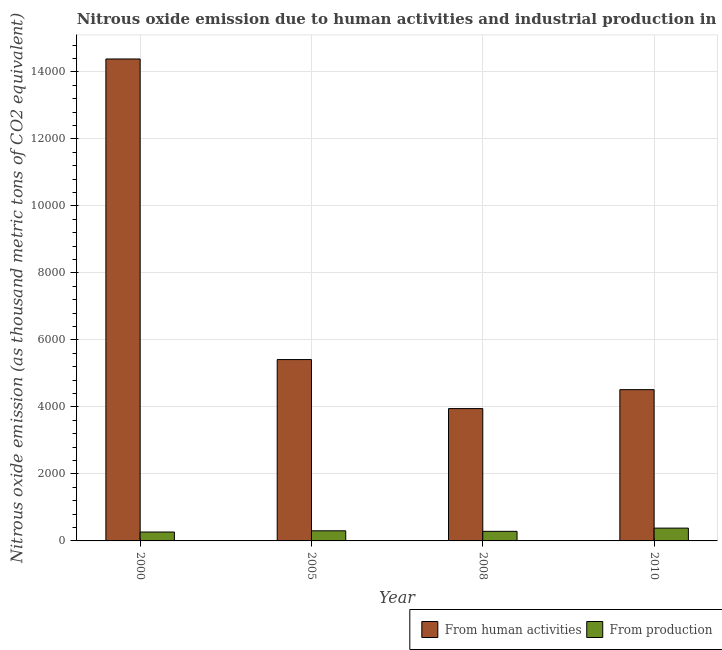How many different coloured bars are there?
Your answer should be very brief. 2. Are the number of bars per tick equal to the number of legend labels?
Provide a succinct answer. Yes. How many bars are there on the 1st tick from the left?
Provide a short and direct response. 2. What is the label of the 2nd group of bars from the left?
Give a very brief answer. 2005. What is the amount of emissions generated from industries in 2010?
Your answer should be compact. 382.1. Across all years, what is the maximum amount of emissions generated from industries?
Give a very brief answer. 382.1. Across all years, what is the minimum amount of emissions from human activities?
Keep it short and to the point. 3950.2. What is the total amount of emissions generated from industries in the graph?
Your answer should be very brief. 1236.1. What is the difference between the amount of emissions generated from industries in 2000 and that in 2010?
Give a very brief answer. -116.5. What is the difference between the amount of emissions generated from industries in 2000 and the amount of emissions from human activities in 2008?
Your answer should be compact. -20.7. What is the average amount of emissions generated from industries per year?
Your answer should be compact. 309.02. In how many years, is the amount of emissions from human activities greater than 12800 thousand metric tons?
Provide a short and direct response. 1. What is the ratio of the amount of emissions generated from industries in 2000 to that in 2008?
Make the answer very short. 0.93. Is the amount of emissions generated from industries in 2005 less than that in 2008?
Keep it short and to the point. No. Is the difference between the amount of emissions generated from industries in 2005 and 2010 greater than the difference between the amount of emissions from human activities in 2005 and 2010?
Your response must be concise. No. What is the difference between the highest and the lowest amount of emissions generated from industries?
Give a very brief answer. 116.5. In how many years, is the amount of emissions from human activities greater than the average amount of emissions from human activities taken over all years?
Provide a succinct answer. 1. Is the sum of the amount of emissions generated from industries in 2005 and 2008 greater than the maximum amount of emissions from human activities across all years?
Make the answer very short. Yes. What does the 1st bar from the left in 2008 represents?
Your answer should be compact. From human activities. What does the 1st bar from the right in 2000 represents?
Offer a very short reply. From production. How many bars are there?
Your answer should be compact. 8. Does the graph contain any zero values?
Your answer should be compact. No. Does the graph contain grids?
Ensure brevity in your answer.  Yes. How many legend labels are there?
Give a very brief answer. 2. How are the legend labels stacked?
Your answer should be very brief. Horizontal. What is the title of the graph?
Provide a succinct answer. Nitrous oxide emission due to human activities and industrial production in Guatemala. What is the label or title of the X-axis?
Your answer should be compact. Year. What is the label or title of the Y-axis?
Provide a short and direct response. Nitrous oxide emission (as thousand metric tons of CO2 equivalent). What is the Nitrous oxide emission (as thousand metric tons of CO2 equivalent) of From human activities in 2000?
Offer a very short reply. 1.44e+04. What is the Nitrous oxide emission (as thousand metric tons of CO2 equivalent) in From production in 2000?
Offer a very short reply. 265.6. What is the Nitrous oxide emission (as thousand metric tons of CO2 equivalent) of From human activities in 2005?
Your response must be concise. 5413.1. What is the Nitrous oxide emission (as thousand metric tons of CO2 equivalent) of From production in 2005?
Your answer should be very brief. 302.1. What is the Nitrous oxide emission (as thousand metric tons of CO2 equivalent) of From human activities in 2008?
Provide a short and direct response. 3950.2. What is the Nitrous oxide emission (as thousand metric tons of CO2 equivalent) in From production in 2008?
Offer a very short reply. 286.3. What is the Nitrous oxide emission (as thousand metric tons of CO2 equivalent) of From human activities in 2010?
Ensure brevity in your answer.  4515.5. What is the Nitrous oxide emission (as thousand metric tons of CO2 equivalent) of From production in 2010?
Keep it short and to the point. 382.1. Across all years, what is the maximum Nitrous oxide emission (as thousand metric tons of CO2 equivalent) of From human activities?
Offer a very short reply. 1.44e+04. Across all years, what is the maximum Nitrous oxide emission (as thousand metric tons of CO2 equivalent) of From production?
Your answer should be compact. 382.1. Across all years, what is the minimum Nitrous oxide emission (as thousand metric tons of CO2 equivalent) of From human activities?
Your answer should be very brief. 3950.2. Across all years, what is the minimum Nitrous oxide emission (as thousand metric tons of CO2 equivalent) of From production?
Ensure brevity in your answer.  265.6. What is the total Nitrous oxide emission (as thousand metric tons of CO2 equivalent) in From human activities in the graph?
Keep it short and to the point. 2.83e+04. What is the total Nitrous oxide emission (as thousand metric tons of CO2 equivalent) in From production in the graph?
Provide a succinct answer. 1236.1. What is the difference between the Nitrous oxide emission (as thousand metric tons of CO2 equivalent) of From human activities in 2000 and that in 2005?
Provide a short and direct response. 8972.6. What is the difference between the Nitrous oxide emission (as thousand metric tons of CO2 equivalent) of From production in 2000 and that in 2005?
Give a very brief answer. -36.5. What is the difference between the Nitrous oxide emission (as thousand metric tons of CO2 equivalent) in From human activities in 2000 and that in 2008?
Ensure brevity in your answer.  1.04e+04. What is the difference between the Nitrous oxide emission (as thousand metric tons of CO2 equivalent) of From production in 2000 and that in 2008?
Offer a terse response. -20.7. What is the difference between the Nitrous oxide emission (as thousand metric tons of CO2 equivalent) in From human activities in 2000 and that in 2010?
Offer a terse response. 9870.2. What is the difference between the Nitrous oxide emission (as thousand metric tons of CO2 equivalent) of From production in 2000 and that in 2010?
Give a very brief answer. -116.5. What is the difference between the Nitrous oxide emission (as thousand metric tons of CO2 equivalent) in From human activities in 2005 and that in 2008?
Your answer should be very brief. 1462.9. What is the difference between the Nitrous oxide emission (as thousand metric tons of CO2 equivalent) of From human activities in 2005 and that in 2010?
Provide a short and direct response. 897.6. What is the difference between the Nitrous oxide emission (as thousand metric tons of CO2 equivalent) of From production in 2005 and that in 2010?
Your response must be concise. -80. What is the difference between the Nitrous oxide emission (as thousand metric tons of CO2 equivalent) in From human activities in 2008 and that in 2010?
Ensure brevity in your answer.  -565.3. What is the difference between the Nitrous oxide emission (as thousand metric tons of CO2 equivalent) of From production in 2008 and that in 2010?
Your answer should be compact. -95.8. What is the difference between the Nitrous oxide emission (as thousand metric tons of CO2 equivalent) of From human activities in 2000 and the Nitrous oxide emission (as thousand metric tons of CO2 equivalent) of From production in 2005?
Provide a short and direct response. 1.41e+04. What is the difference between the Nitrous oxide emission (as thousand metric tons of CO2 equivalent) of From human activities in 2000 and the Nitrous oxide emission (as thousand metric tons of CO2 equivalent) of From production in 2008?
Offer a very short reply. 1.41e+04. What is the difference between the Nitrous oxide emission (as thousand metric tons of CO2 equivalent) in From human activities in 2000 and the Nitrous oxide emission (as thousand metric tons of CO2 equivalent) in From production in 2010?
Ensure brevity in your answer.  1.40e+04. What is the difference between the Nitrous oxide emission (as thousand metric tons of CO2 equivalent) in From human activities in 2005 and the Nitrous oxide emission (as thousand metric tons of CO2 equivalent) in From production in 2008?
Your answer should be very brief. 5126.8. What is the difference between the Nitrous oxide emission (as thousand metric tons of CO2 equivalent) of From human activities in 2005 and the Nitrous oxide emission (as thousand metric tons of CO2 equivalent) of From production in 2010?
Your answer should be compact. 5031. What is the difference between the Nitrous oxide emission (as thousand metric tons of CO2 equivalent) of From human activities in 2008 and the Nitrous oxide emission (as thousand metric tons of CO2 equivalent) of From production in 2010?
Keep it short and to the point. 3568.1. What is the average Nitrous oxide emission (as thousand metric tons of CO2 equivalent) in From human activities per year?
Give a very brief answer. 7066.12. What is the average Nitrous oxide emission (as thousand metric tons of CO2 equivalent) of From production per year?
Provide a short and direct response. 309.02. In the year 2000, what is the difference between the Nitrous oxide emission (as thousand metric tons of CO2 equivalent) of From human activities and Nitrous oxide emission (as thousand metric tons of CO2 equivalent) of From production?
Provide a short and direct response. 1.41e+04. In the year 2005, what is the difference between the Nitrous oxide emission (as thousand metric tons of CO2 equivalent) of From human activities and Nitrous oxide emission (as thousand metric tons of CO2 equivalent) of From production?
Your answer should be very brief. 5111. In the year 2008, what is the difference between the Nitrous oxide emission (as thousand metric tons of CO2 equivalent) in From human activities and Nitrous oxide emission (as thousand metric tons of CO2 equivalent) in From production?
Offer a very short reply. 3663.9. In the year 2010, what is the difference between the Nitrous oxide emission (as thousand metric tons of CO2 equivalent) of From human activities and Nitrous oxide emission (as thousand metric tons of CO2 equivalent) of From production?
Offer a very short reply. 4133.4. What is the ratio of the Nitrous oxide emission (as thousand metric tons of CO2 equivalent) in From human activities in 2000 to that in 2005?
Your answer should be compact. 2.66. What is the ratio of the Nitrous oxide emission (as thousand metric tons of CO2 equivalent) of From production in 2000 to that in 2005?
Your response must be concise. 0.88. What is the ratio of the Nitrous oxide emission (as thousand metric tons of CO2 equivalent) of From human activities in 2000 to that in 2008?
Your answer should be compact. 3.64. What is the ratio of the Nitrous oxide emission (as thousand metric tons of CO2 equivalent) of From production in 2000 to that in 2008?
Make the answer very short. 0.93. What is the ratio of the Nitrous oxide emission (as thousand metric tons of CO2 equivalent) in From human activities in 2000 to that in 2010?
Your answer should be compact. 3.19. What is the ratio of the Nitrous oxide emission (as thousand metric tons of CO2 equivalent) of From production in 2000 to that in 2010?
Ensure brevity in your answer.  0.7. What is the ratio of the Nitrous oxide emission (as thousand metric tons of CO2 equivalent) of From human activities in 2005 to that in 2008?
Offer a terse response. 1.37. What is the ratio of the Nitrous oxide emission (as thousand metric tons of CO2 equivalent) of From production in 2005 to that in 2008?
Your answer should be compact. 1.06. What is the ratio of the Nitrous oxide emission (as thousand metric tons of CO2 equivalent) of From human activities in 2005 to that in 2010?
Your answer should be very brief. 1.2. What is the ratio of the Nitrous oxide emission (as thousand metric tons of CO2 equivalent) of From production in 2005 to that in 2010?
Give a very brief answer. 0.79. What is the ratio of the Nitrous oxide emission (as thousand metric tons of CO2 equivalent) of From human activities in 2008 to that in 2010?
Your answer should be very brief. 0.87. What is the ratio of the Nitrous oxide emission (as thousand metric tons of CO2 equivalent) of From production in 2008 to that in 2010?
Keep it short and to the point. 0.75. What is the difference between the highest and the second highest Nitrous oxide emission (as thousand metric tons of CO2 equivalent) in From human activities?
Ensure brevity in your answer.  8972.6. What is the difference between the highest and the second highest Nitrous oxide emission (as thousand metric tons of CO2 equivalent) in From production?
Your answer should be compact. 80. What is the difference between the highest and the lowest Nitrous oxide emission (as thousand metric tons of CO2 equivalent) in From human activities?
Ensure brevity in your answer.  1.04e+04. What is the difference between the highest and the lowest Nitrous oxide emission (as thousand metric tons of CO2 equivalent) in From production?
Provide a succinct answer. 116.5. 